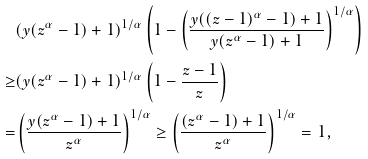<formula> <loc_0><loc_0><loc_500><loc_500>& ( y ( z ^ { \alpha } - 1 ) + 1 ) ^ { 1 / \alpha } \left ( 1 - \left ( \frac { y ( ( z - 1 ) ^ { \alpha } - 1 ) + 1 } { y ( z ^ { \alpha } - 1 ) + 1 } \right ) ^ { 1 / \alpha } \right ) \\ \geq & ( y ( z ^ { \alpha } - 1 ) + 1 ) ^ { 1 / \alpha } \left ( 1 - \frac { z - 1 } { z } \right ) \\ = & \left ( \frac { y ( z ^ { \alpha } - 1 ) + 1 } { z ^ { \alpha } } \right ) ^ { 1 / \alpha } \geq \left ( \frac { ( z ^ { \alpha } - 1 ) + 1 } { z ^ { \alpha } } \right ) ^ { 1 / \alpha } = 1 ,</formula> 